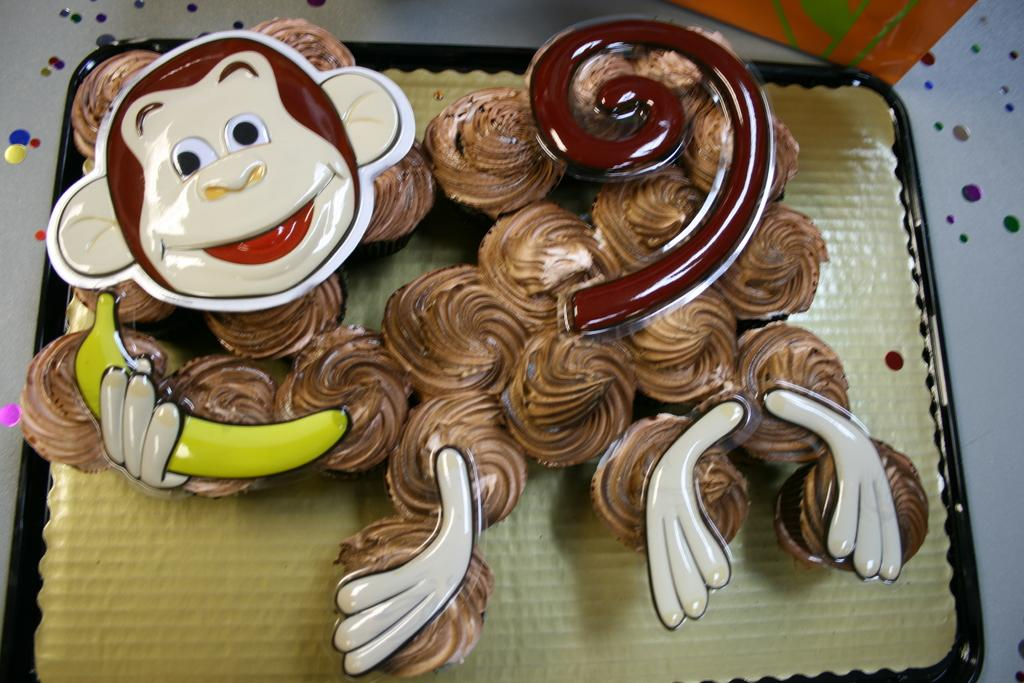What type of dessert can be seen in the image? There are cupcakes in the image. How are the cupcakes arranged or presented? The cupcakes are placed on a tray. What color is the orange object in the image? The facts do not specify the color of the orange object. What is on top of the cupcakes? The cupcakes have cream on them and monkey mask designs. What type of lizards can be seen participating in a battle in the image? There are no lizards or battles present in the image; it features cupcakes with monkey mask designs. 